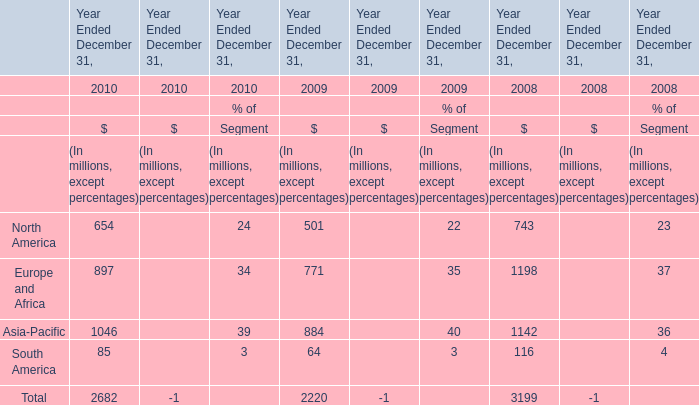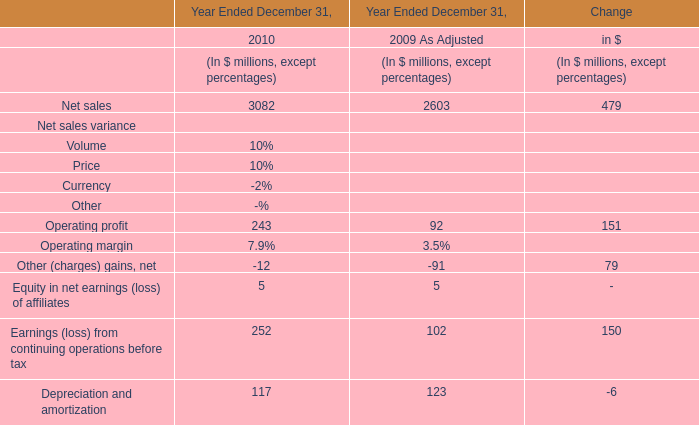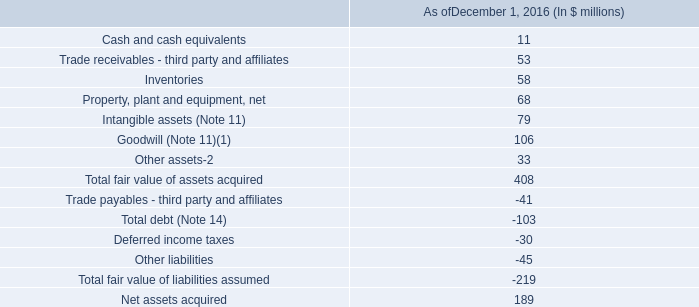What is the total value of North America, Europe and Africa, Asia-Pacific and South America in 2010? (in million) 
Computations: (((654 + 897) + 1046) + 85)
Answer: 2682.0. 